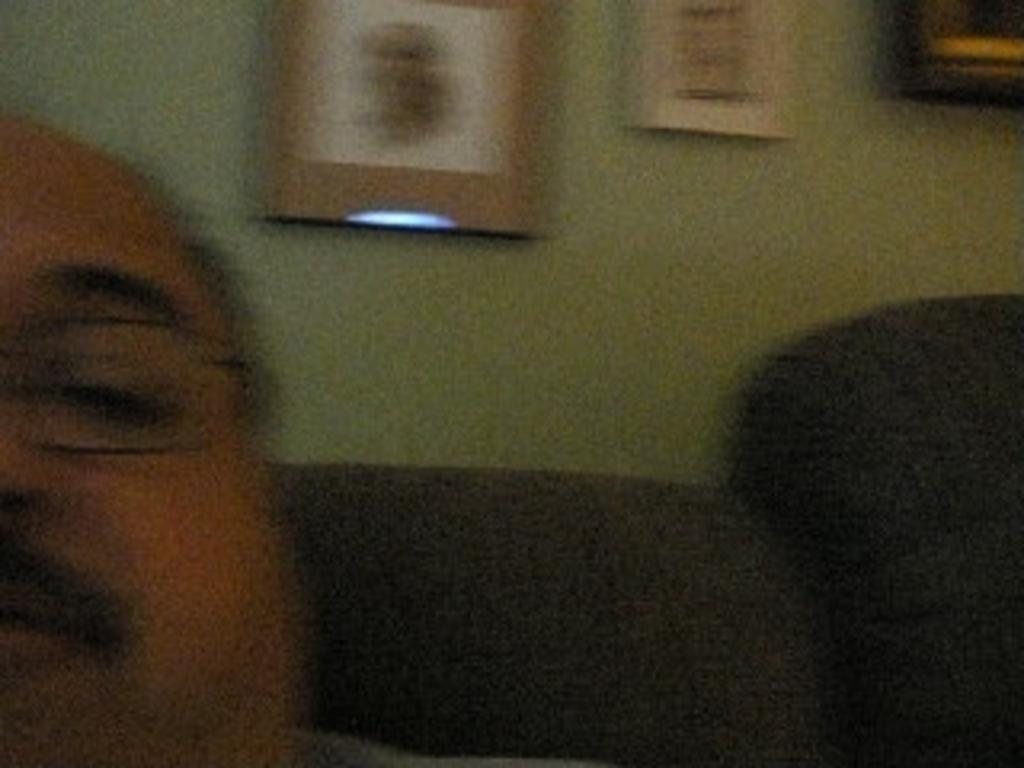Who is present in the image? There is a man in the image. What is the man wearing in the image? The man is wearing spectacles in the image. What can be seen in the background of the image? There are photos and other objects attached to the wall in the background of the image. What type of collar can be seen on the doll in the image? There is no doll present in the image, so there is no collar to be seen. 